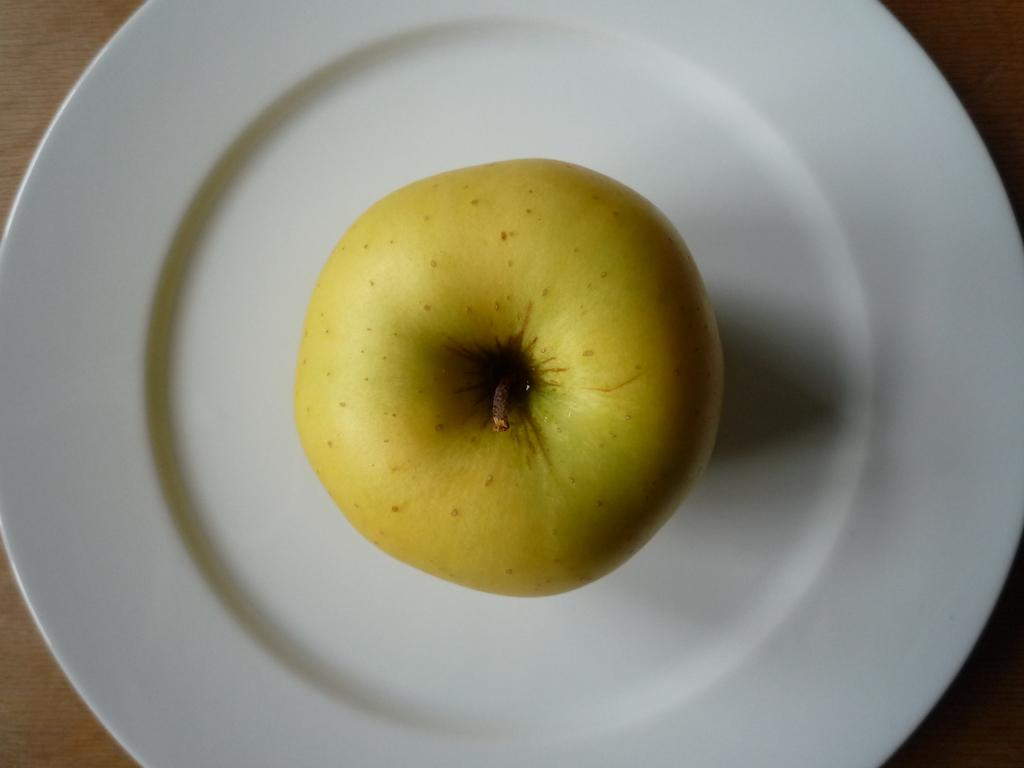What is the main subject of the image? There is a fruit on a plate in the image. Can you describe the fruit in more detail? Unfortunately, the specific type of fruit cannot be determined from the image alone. Is there anything else on the plate with the fruit? The provided facts do not mention any additional items on the plate. What type of pancake is being served with the fruit in the image? There is no pancake present in the image; it only features a fruit on a plate. Can you hear the fruit being sliced in the image? The image is a still photograph and does not contain any auditory information, so it is impossible to hear the fruit being sliced. 